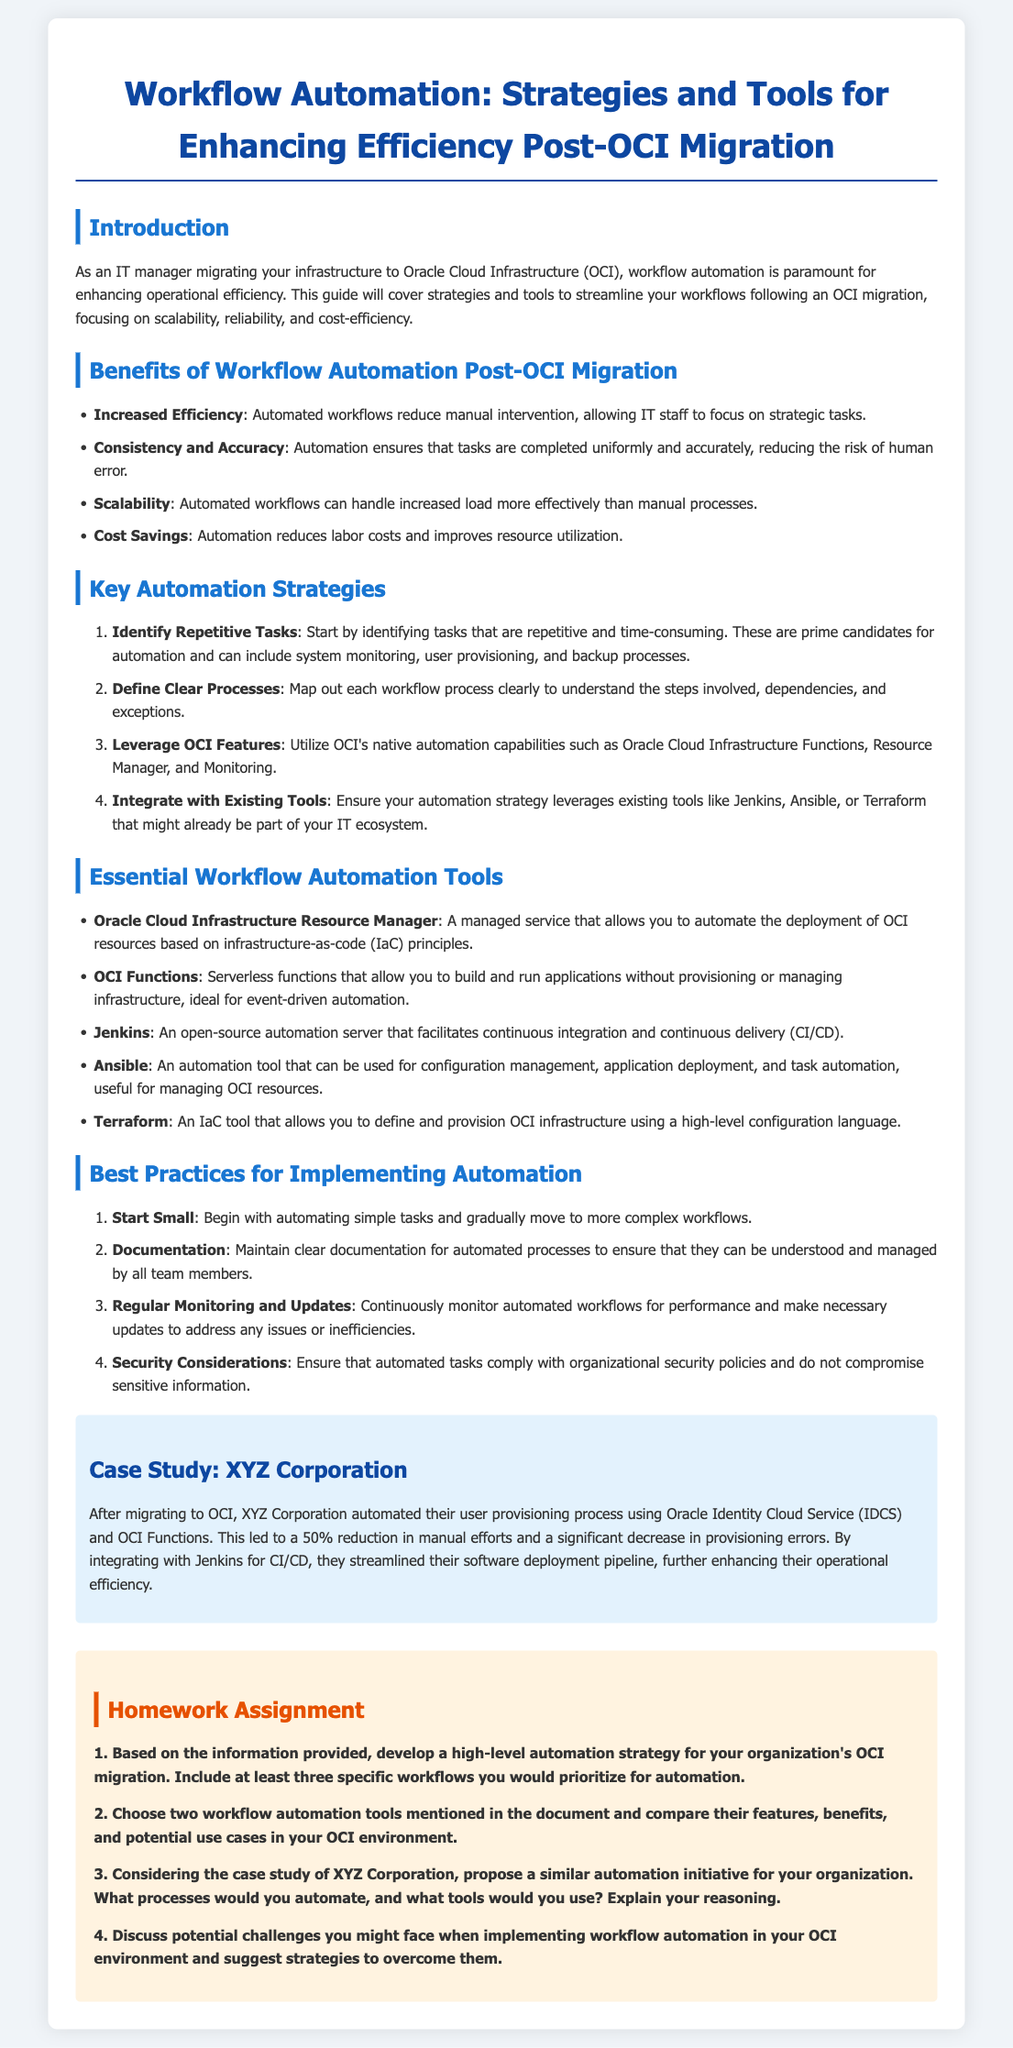What is the title of the document? The title is clearly stated at the top of the document and reflects the main topic being discussed.
Answer: Workflow Automation: Strategies and Tools for Enhancing Efficiency Post-OCI Migration What is one benefit of workflow automation after OCI migration? The document lists several benefits in the benefits section, highlighting the advantages gained post-migration.
Answer: Increased Efficiency Name a key automation strategy mentioned in the document. The document outlines multiple strategies that are essential for implementing automation successfully.
Answer: Identify Repetitive Tasks Which tool is described as a serverless function for event-driven automation? In the tools section, the document provides information about various tools and their functions, helping to identify their uses.
Answer: OCI Functions What percentage reduction in manual efforts did XYZ Corporation achieve after automation? The case study provides specific metrics that illustrate the effectiveness of automation in the organization's processes.
Answer: 50% List one best practice for implementing automation. The document provides a list of best practices that can guide organizations as they implement automation strategies.
Answer: Start Small How many key automation strategies are mentioned in total? The document clearly enumerates the strategies, allowing for easy tallying of the count.
Answer: Four What color is used for the background of the case study section? The document mentions specific styling choices including colors for different sections including the case study.
Answer: Light blue 